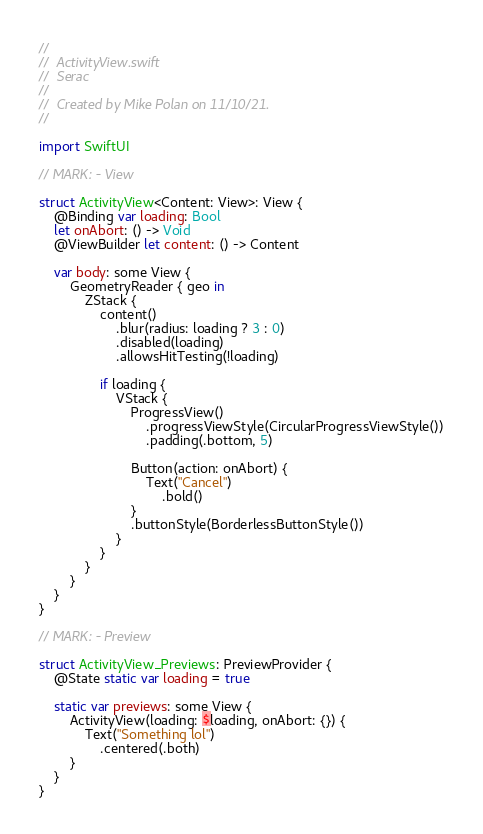Convert code to text. <code><loc_0><loc_0><loc_500><loc_500><_Swift_>//
//  ActivityView.swift
//  Serac
//
//  Created by Mike Polan on 11/10/21.
//

import SwiftUI

// MARK: - View

struct ActivityView<Content: View>: View {
    @Binding var loading: Bool
    let onAbort: () -> Void
    @ViewBuilder let content: () -> Content
    
    var body: some View {
        GeometryReader { geo in
            ZStack {
                content()
                    .blur(radius: loading ? 3 : 0)
                    .disabled(loading)
                    .allowsHitTesting(!loading)
                
                if loading {
                    VStack {
                        ProgressView()
                            .progressViewStyle(CircularProgressViewStyle())
                            .padding(.bottom, 5)
                        
                        Button(action: onAbort) {
                            Text("Cancel")
                                .bold()
                        }
                        .buttonStyle(BorderlessButtonStyle())
                    }
                }
            }
        }
    }
}

// MARK: - Preview

struct ActivityView_Previews: PreviewProvider {
    @State static var loading = true
    
    static var previews: some View {
        ActivityView(loading: $loading, onAbort: {}) {
            Text("Something lol")
                .centered(.both)
        }
    }
}
</code> 